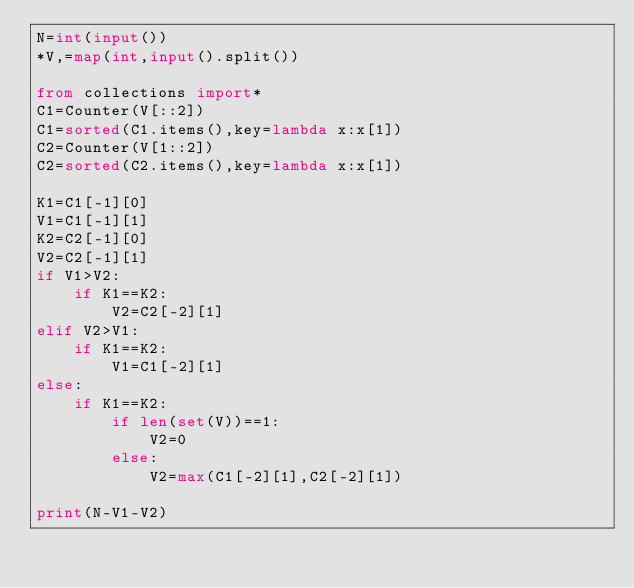Convert code to text. <code><loc_0><loc_0><loc_500><loc_500><_Python_>N=int(input())
*V,=map(int,input().split())

from collections import*
C1=Counter(V[::2])
C1=sorted(C1.items(),key=lambda x:x[1])
C2=Counter(V[1::2])
C2=sorted(C2.items(),key=lambda x:x[1])

K1=C1[-1][0]
V1=C1[-1][1]
K2=C2[-1][0]
V2=C2[-1][1]
if V1>V2:
    if K1==K2:
        V2=C2[-2][1]
elif V2>V1:
    if K1==K2:
        V1=C1[-2][1]
else:
    if K1==K2:
        if len(set(V))==1:
            V2=0
        else:
            V2=max(C1[-2][1],C2[-2][1])

print(N-V1-V2)</code> 